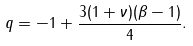Convert formula to latex. <formula><loc_0><loc_0><loc_500><loc_500>q = - 1 + \frac { 3 ( 1 + \nu ) ( \beta - 1 ) } { 4 } .</formula> 